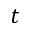Convert formula to latex. <formula><loc_0><loc_0><loc_500><loc_500>t</formula> 